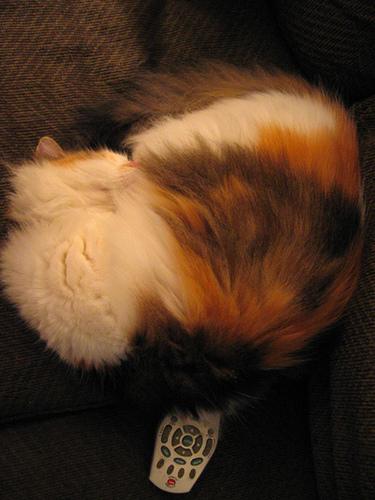Is this cat sleeping?
Quick response, please. Yes. Is the cat happy?
Quick response, please. Yes. Is the cat awake or asleep?
Give a very brief answer. Asleep. What color is the remote control?
Short answer required. Gray. Is the kitty looking into or away from the camera?
Write a very short answer. Away. Is this a dog or cat?
Be succinct. Cat. What is the cat laying on?
Be succinct. Remote. What is next to the cat's head?
Be succinct. Remote. What color is the cat?
Quick response, please. Calico. 